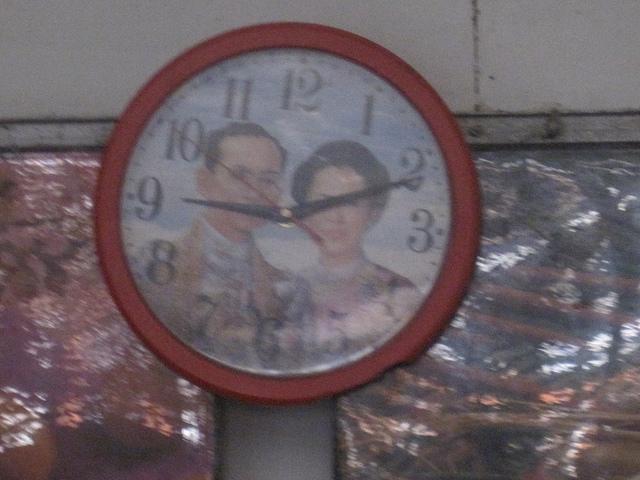Whose face is on the clock?
Give a very brief answer. Man and woman. Did the man on the picture sign this clock?
Write a very short answer. No. What type of numerals are on the clock face?
Give a very brief answer. Regular. What time is it?
Answer briefly. 9:11. Is this clock outside?
Quick response, please. No. What is the round object in the center of the photo?
Keep it brief. Clock. 